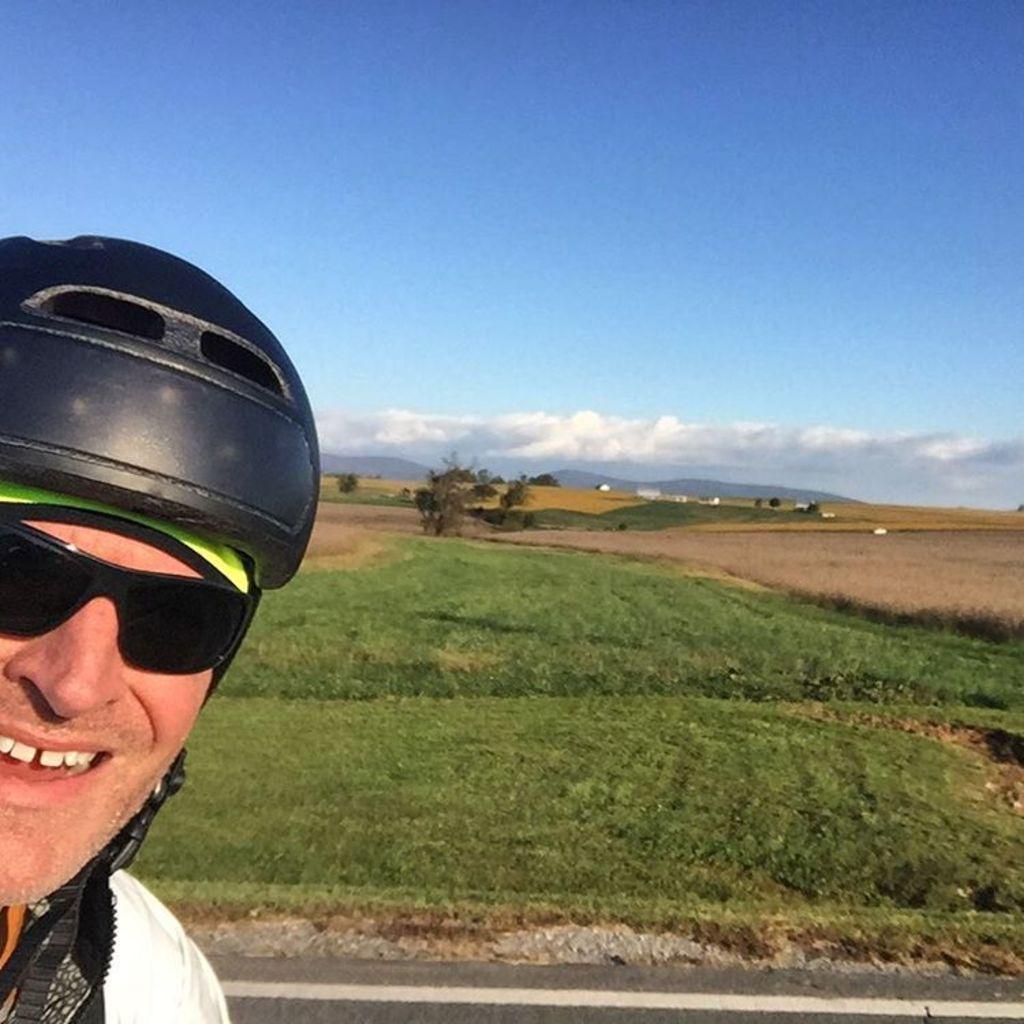How would you summarize this image in a sentence or two? In this image in the foreground there is one person who is wearing a helmet and smiling, in the background there are some trees, mountains and grass. At the bottom there is a road and at the top of the image there is sky. 